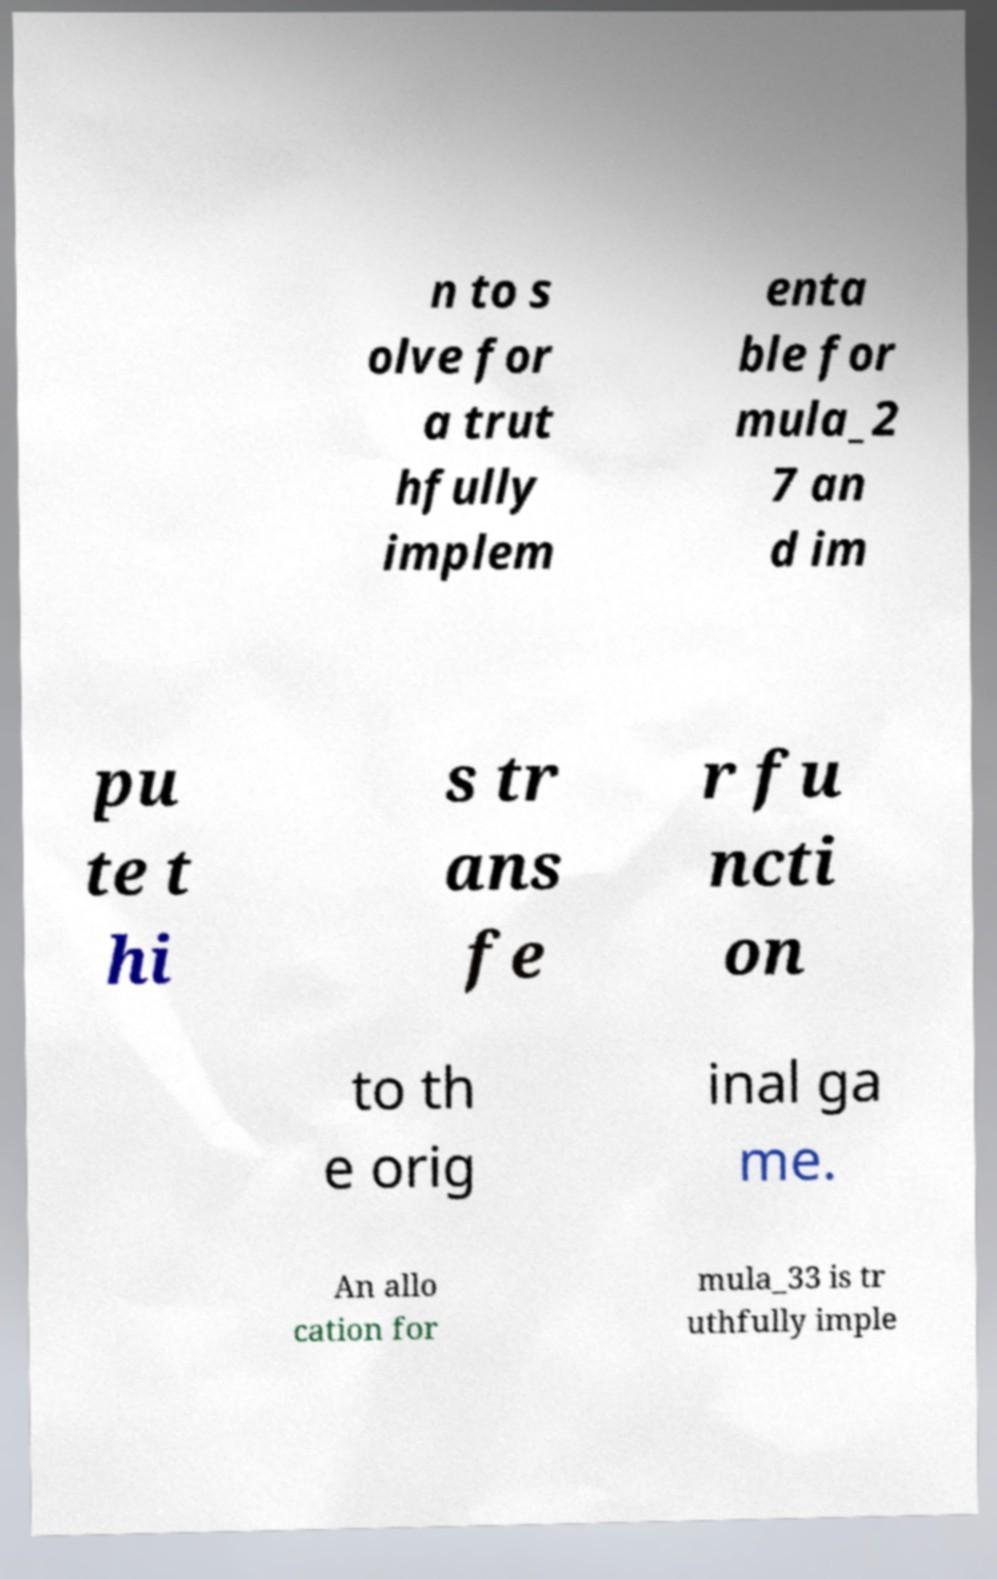Please identify and transcribe the text found in this image. n to s olve for a trut hfully implem enta ble for mula_2 7 an d im pu te t hi s tr ans fe r fu ncti on to th e orig inal ga me. An allo cation for mula_33 is tr uthfully imple 